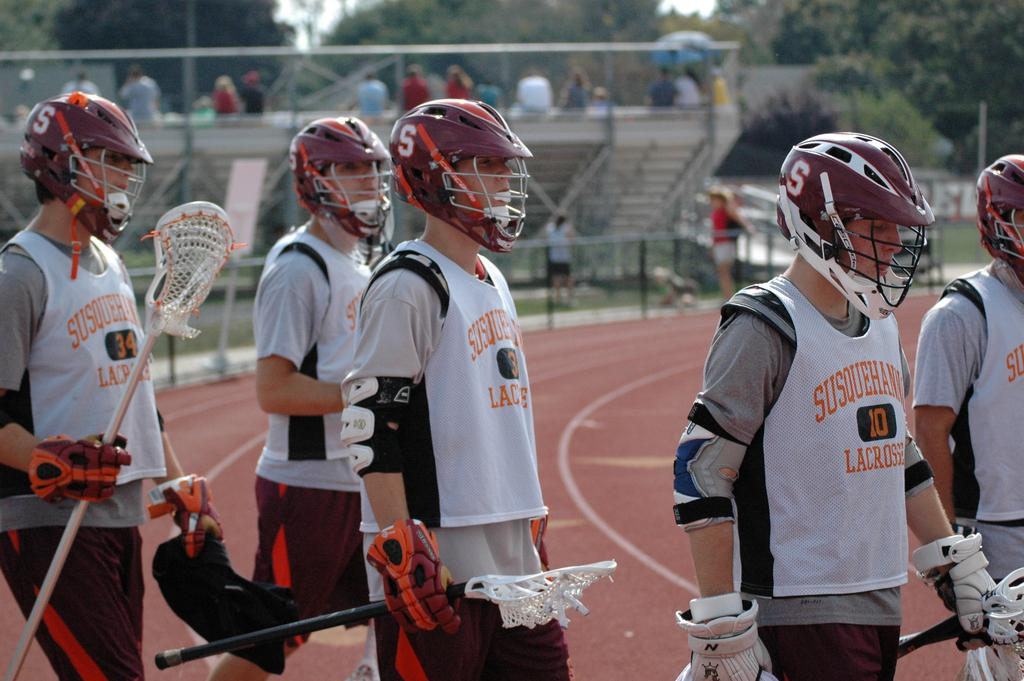How many people are in the image? There are many people in the image. What are the people wearing on their heads? The people are wearing helmets. What are the people wearing on their hands? The people are wearing gloves. What are some people holding in the image? Some people are holding bats. What can be seen in the background of the image? The background of the image is blurred, but there are steps, trees, and people visible. What type of flame can be seen on the people's helmets in the image? There is no flame present on the people's helmets in the image. Are there any bears visible in the image? There are no bears present in the image. 